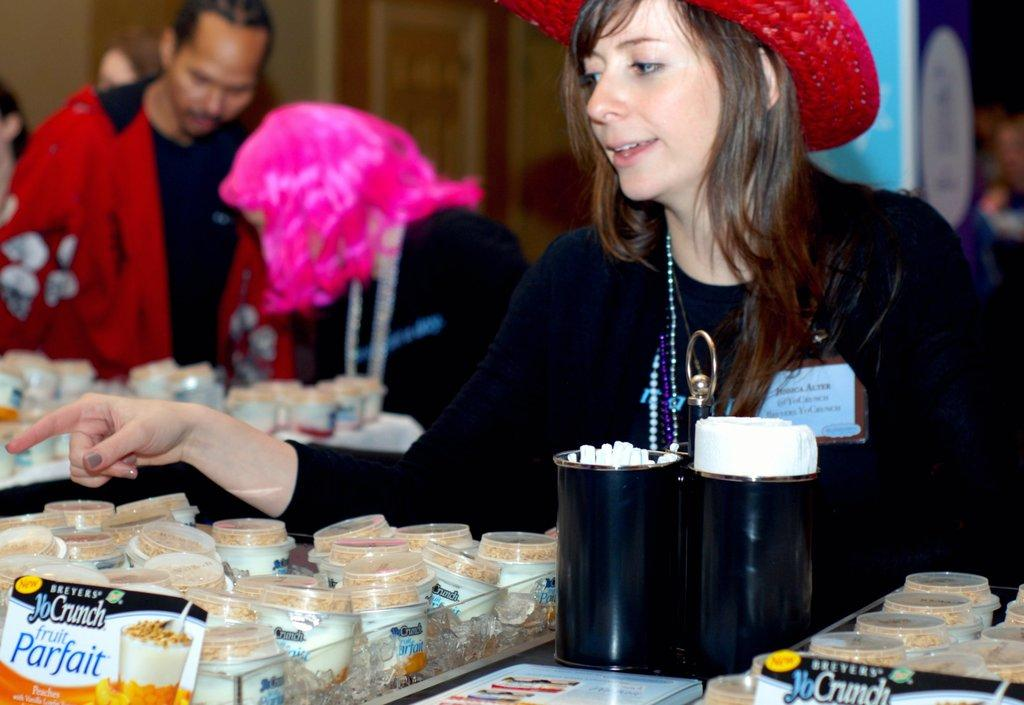How many people are present in the image? There are three persons in the image. What objects can be seen in the image besides the people? There are boxes, a food packet, tissue papers, and cups in the image. Can you describe the background of the image? The background of the image is blurred. What type of fruit is being spread on the jam in the image? There is no fruit or jam present in the image. What kind of cloud formation can be seen in the background of the image? The background of the image is blurred, and there is no cloud formation visible. 